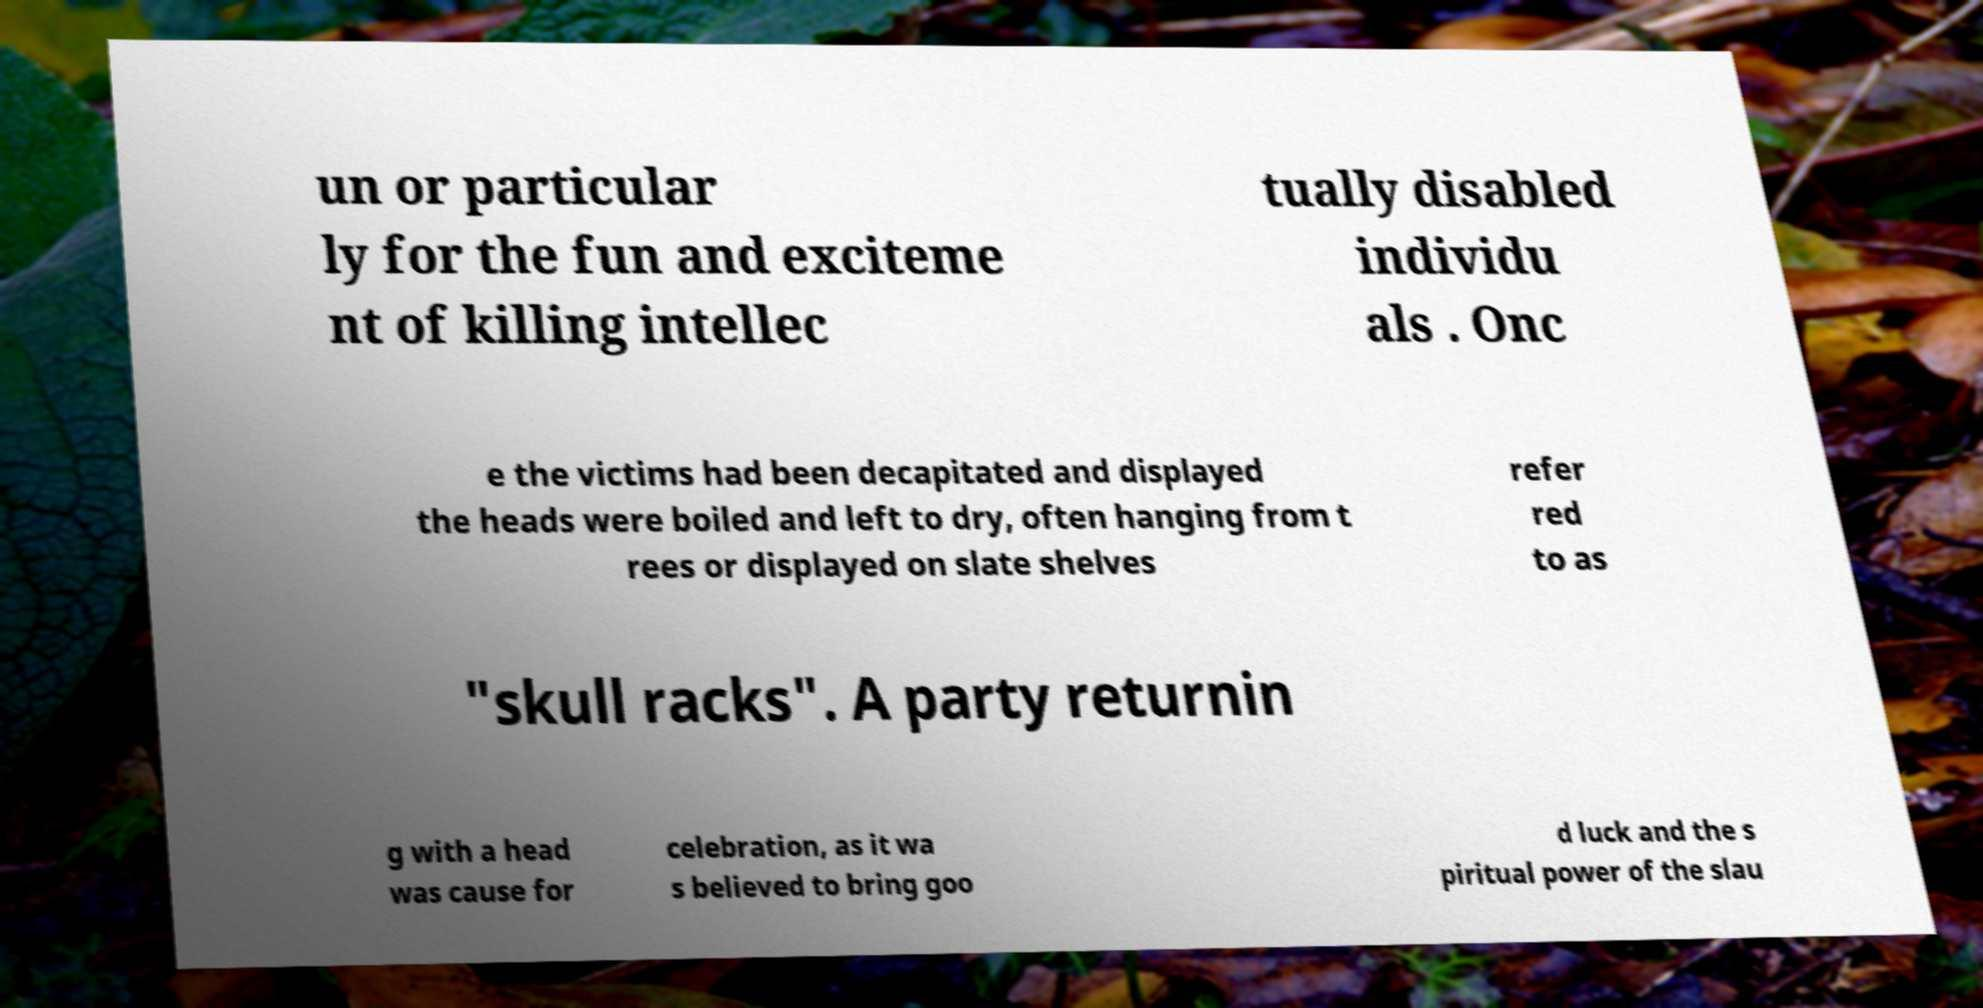Please identify and transcribe the text found in this image. un or particular ly for the fun and exciteme nt of killing intellec tually disabled individu als . Onc e the victims had been decapitated and displayed the heads were boiled and left to dry, often hanging from t rees or displayed on slate shelves refer red to as "skull racks". A party returnin g with a head was cause for celebration, as it wa s believed to bring goo d luck and the s piritual power of the slau 